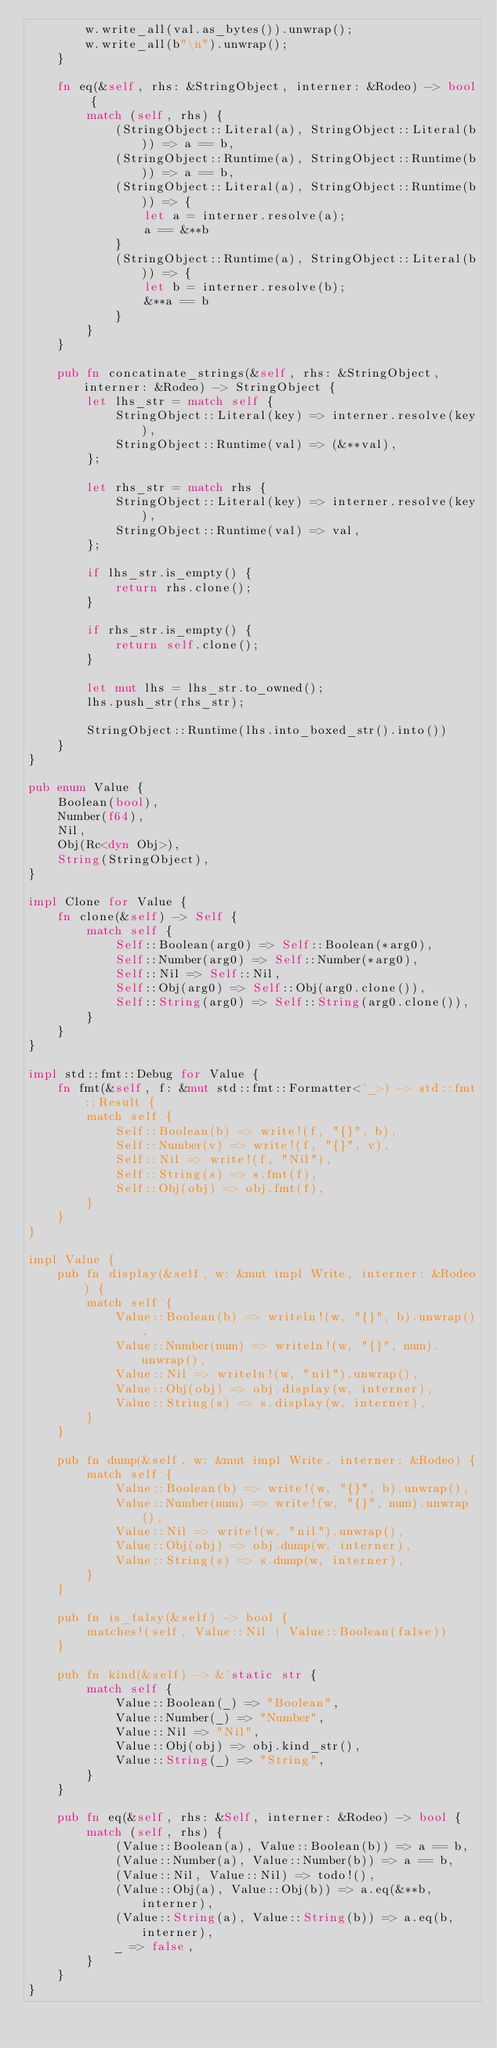<code> <loc_0><loc_0><loc_500><loc_500><_Rust_>        w.write_all(val.as_bytes()).unwrap();
        w.write_all(b"\n").unwrap();
    }

    fn eq(&self, rhs: &StringObject, interner: &Rodeo) -> bool {
        match (self, rhs) {
            (StringObject::Literal(a), StringObject::Literal(b)) => a == b,
            (StringObject::Runtime(a), StringObject::Runtime(b)) => a == b,
            (StringObject::Literal(a), StringObject::Runtime(b)) => {
                let a = interner.resolve(a);
                a == &**b
            }
            (StringObject::Runtime(a), StringObject::Literal(b)) => {
                let b = interner.resolve(b);
                &**a == b
            }
        }
    }

    pub fn concatinate_strings(&self, rhs: &StringObject, interner: &Rodeo) -> StringObject {
        let lhs_str = match self {
            StringObject::Literal(key) => interner.resolve(key),
            StringObject::Runtime(val) => (&**val),
        };

        let rhs_str = match rhs {
            StringObject::Literal(key) => interner.resolve(key),
            StringObject::Runtime(val) => val,
        };

        if lhs_str.is_empty() {
            return rhs.clone();
        }

        if rhs_str.is_empty() {
            return self.clone();
        }

        let mut lhs = lhs_str.to_owned();
        lhs.push_str(rhs_str);

        StringObject::Runtime(lhs.into_boxed_str().into())
    }
}

pub enum Value {
    Boolean(bool),
    Number(f64),
    Nil,
    Obj(Rc<dyn Obj>),
    String(StringObject),
}

impl Clone for Value {
    fn clone(&self) -> Self {
        match self {
            Self::Boolean(arg0) => Self::Boolean(*arg0),
            Self::Number(arg0) => Self::Number(*arg0),
            Self::Nil => Self::Nil,
            Self::Obj(arg0) => Self::Obj(arg0.clone()),
            Self::String(arg0) => Self::String(arg0.clone()),
        }
    }
}

impl std::fmt::Debug for Value {
    fn fmt(&self, f: &mut std::fmt::Formatter<'_>) -> std::fmt::Result {
        match self {
            Self::Boolean(b) => write!(f, "{}", b),
            Self::Number(v) => write!(f, "{}", v),
            Self::Nil => write!(f, "Nil"),
            Self::String(s) => s.fmt(f),
            Self::Obj(obj) => obj.fmt(f),
        }
    }
}

impl Value {
    pub fn display(&self, w: &mut impl Write, interner: &Rodeo) {
        match self {
            Value::Boolean(b) => writeln!(w, "{}", b).unwrap(),
            Value::Number(num) => writeln!(w, "{}", num).unwrap(),
            Value::Nil => writeln!(w, "nil").unwrap(),
            Value::Obj(obj) => obj.display(w, interner),
            Value::String(s) => s.display(w, interner),
        }
    }

    pub fn dump(&self, w: &mut impl Write, interner: &Rodeo) {
        match self {
            Value::Boolean(b) => write!(w, "{}", b).unwrap(),
            Value::Number(num) => write!(w, "{}", num).unwrap(),
            Value::Nil => write!(w, "nil").unwrap(),
            Value::Obj(obj) => obj.dump(w, interner),
            Value::String(s) => s.dump(w, interner),
        }
    }

    pub fn is_falsy(&self) -> bool {
        matches!(self, Value::Nil | Value::Boolean(false))
    }

    pub fn kind(&self) -> &'static str {
        match self {
            Value::Boolean(_) => "Boolean",
            Value::Number(_) => "Number",
            Value::Nil => "Nil",
            Value::Obj(obj) => obj.kind_str(),
            Value::String(_) => "String",
        }
    }

    pub fn eq(&self, rhs: &Self, interner: &Rodeo) -> bool {
        match (self, rhs) {
            (Value::Boolean(a), Value::Boolean(b)) => a == b,
            (Value::Number(a), Value::Number(b)) => a == b,
            (Value::Nil, Value::Nil) => todo!(),
            (Value::Obj(a), Value::Obj(b)) => a.eq(&**b, interner),
            (Value::String(a), Value::String(b)) => a.eq(b, interner),
            _ => false,
        }
    }
}
</code> 